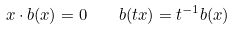Convert formula to latex. <formula><loc_0><loc_0><loc_500><loc_500>x \cdot b ( x ) = 0 \quad b ( t x ) = t ^ { - 1 } b ( x )</formula> 